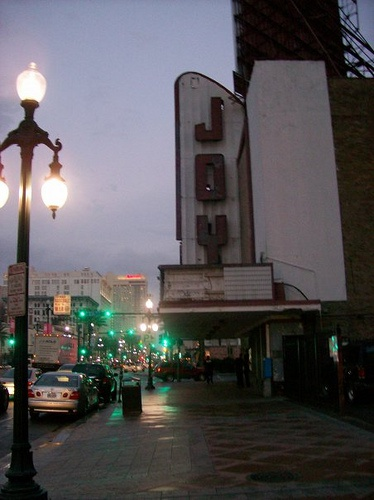Describe the objects in this image and their specific colors. I can see car in gray, black, and darkgray tones, car in gray, black, darkgreen, and teal tones, truck in gray, black, and maroon tones, car in gray, black, maroon, and darkgreen tones, and truck in gray, black, maroon, and darkgreen tones in this image. 